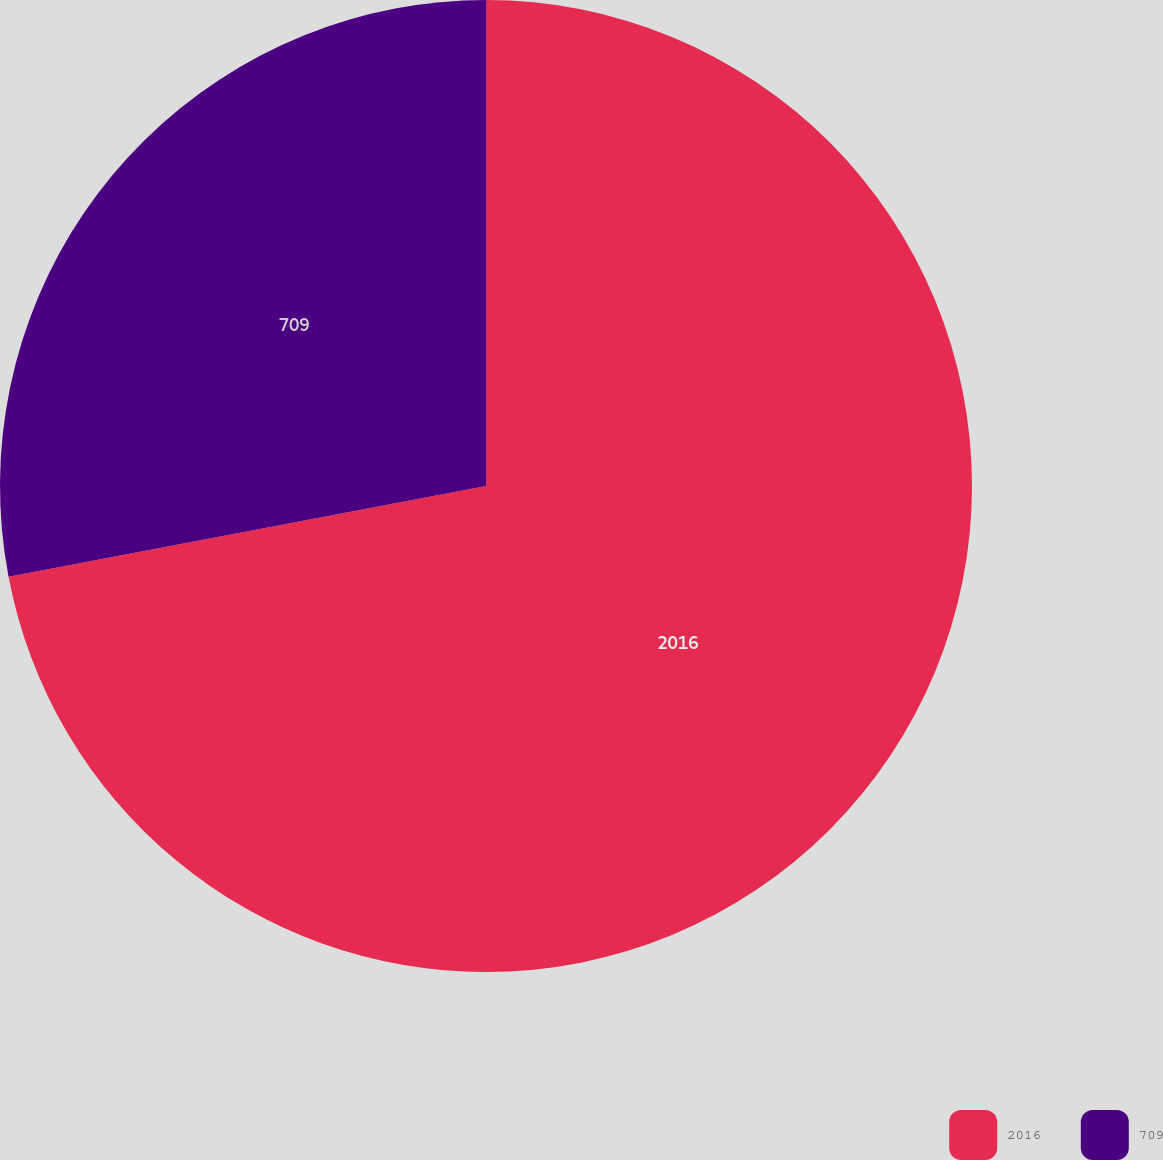<chart> <loc_0><loc_0><loc_500><loc_500><pie_chart><fcel>2016<fcel>709<nl><fcel>72.01%<fcel>27.99%<nl></chart> 